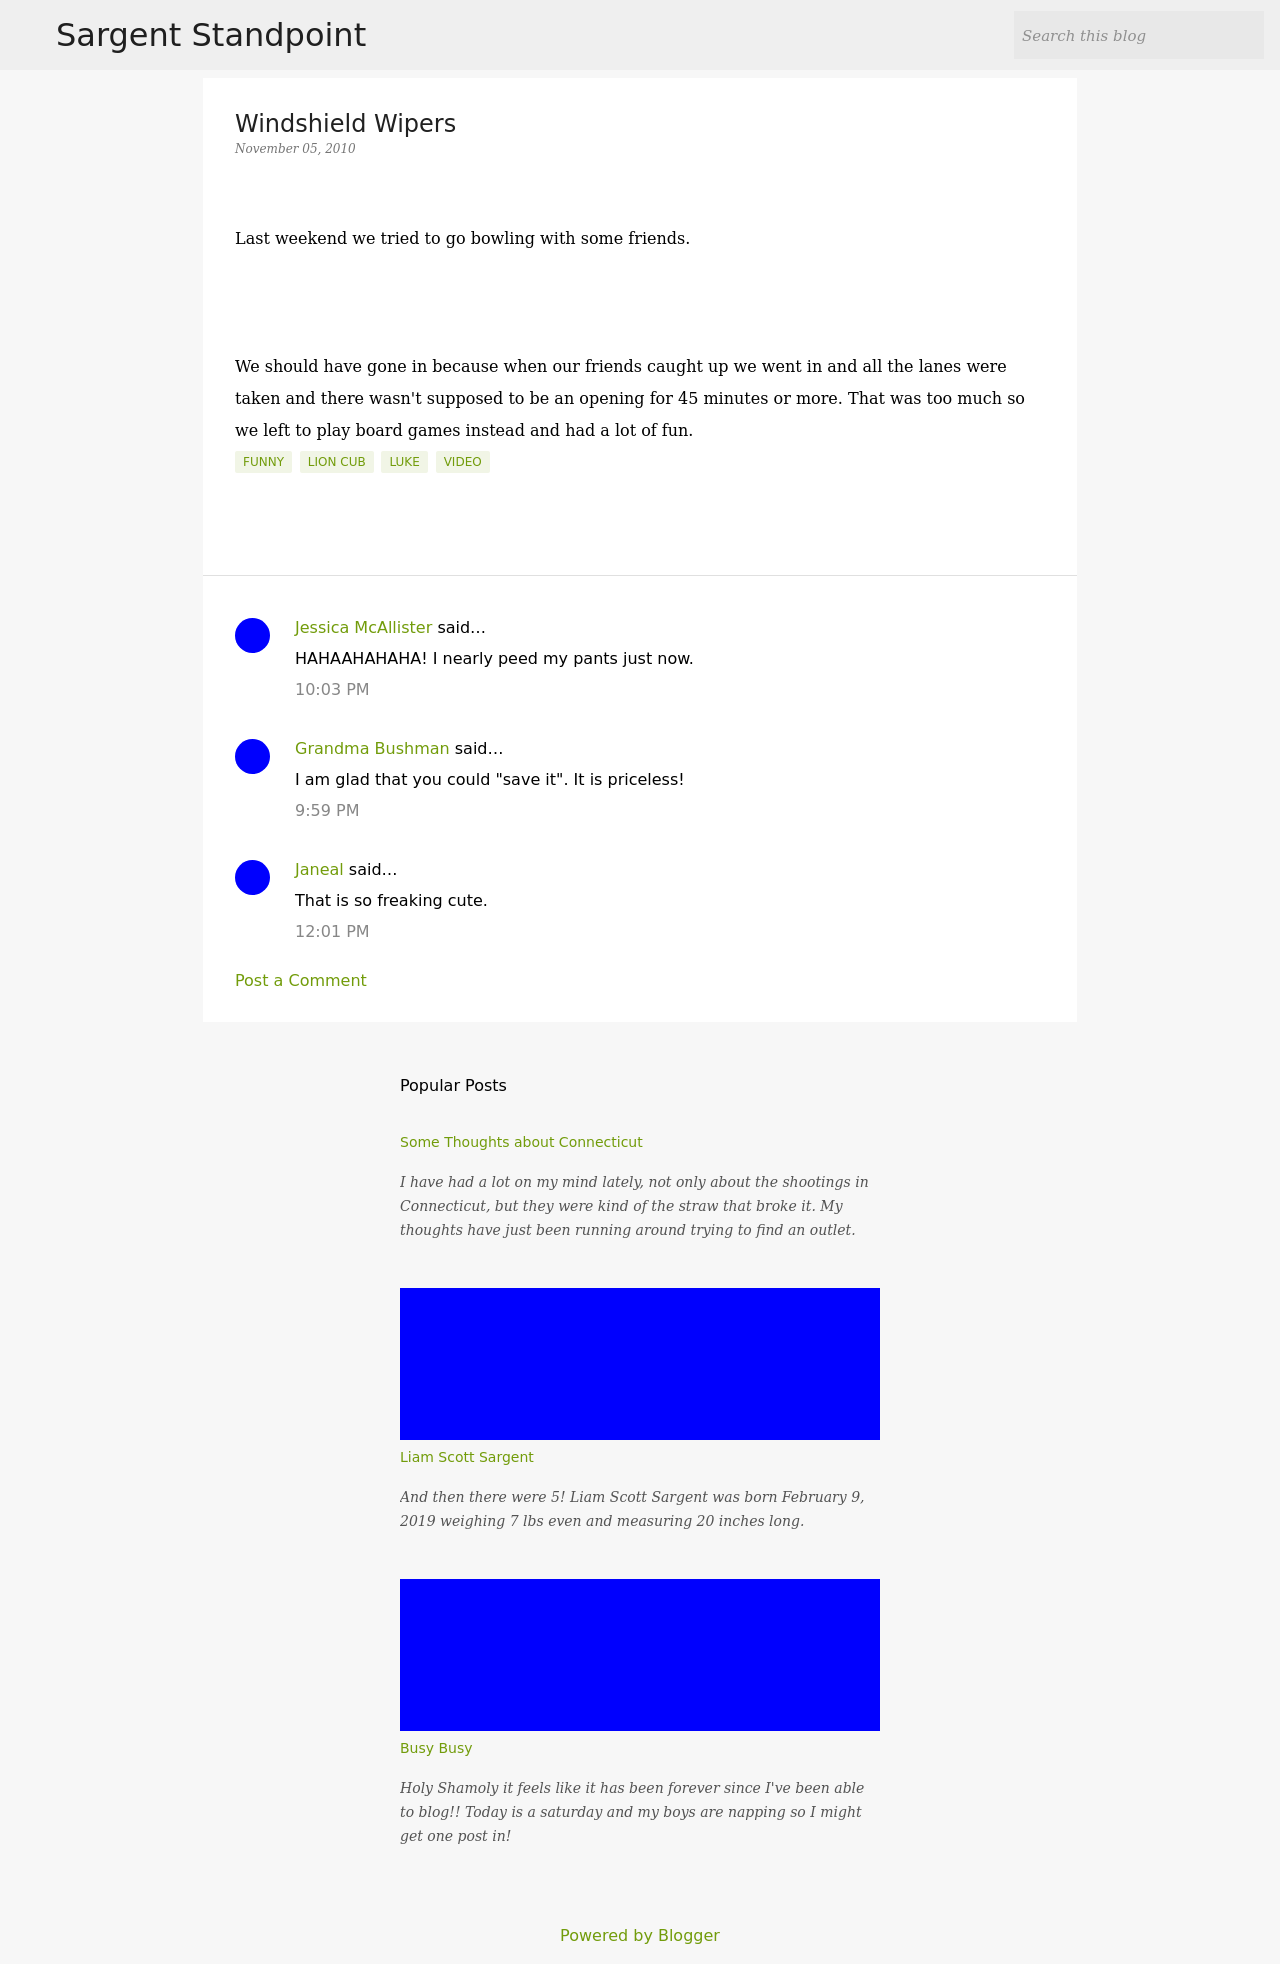What's the procedure for constructing this website from scratch with HTML? To construct a blog website similar to the one shown from scratch using HTML, start by setting up the basic HTML structure with DOCTYPE, html, head, and body tags. Include meta tags for viewport and character set settings for responsiveness and encoding. Use title and style tags within the head for webpage title and CSS styles. In the body, layout the main components such as header, main content, sidebar, and footer using semantic HTML5 tags like header, main, article, aside, and footer. Populate these sections with relevant content and style them for appearance. Also, don't forget to include meta tags for SEO optimization and link necessary external stylesheets and scripts for additional functionalities. 